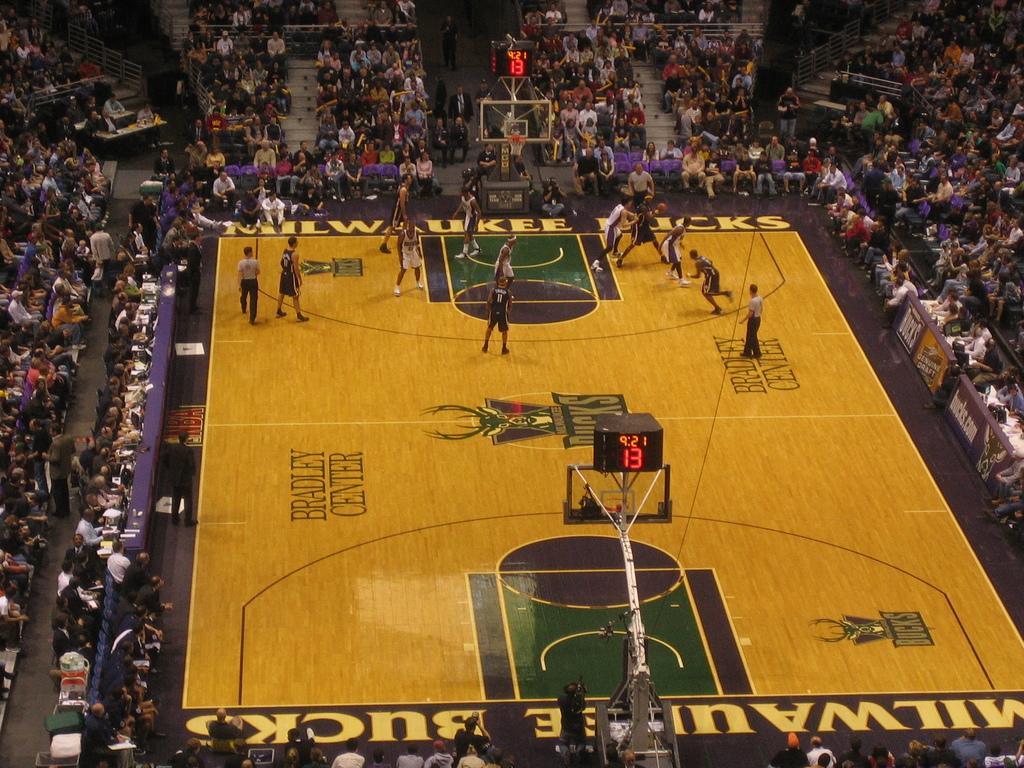How would you summarize this image in a sentence or two? In this picture I can see there is a playground and there are few people inside the playground and there are audience sitting around them. There is a scoreboard here. 